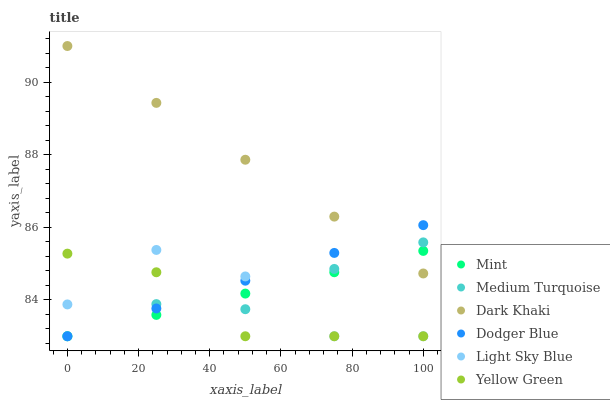Does Yellow Green have the minimum area under the curve?
Answer yes or no. Yes. Does Dark Khaki have the maximum area under the curve?
Answer yes or no. Yes. Does Light Sky Blue have the minimum area under the curve?
Answer yes or no. No. Does Light Sky Blue have the maximum area under the curve?
Answer yes or no. No. Is Dodger Blue the smoothest?
Answer yes or no. Yes. Is Light Sky Blue the roughest?
Answer yes or no. Yes. Is Dark Khaki the smoothest?
Answer yes or no. No. Is Dark Khaki the roughest?
Answer yes or no. No. Does Yellow Green have the lowest value?
Answer yes or no. Yes. Does Dark Khaki have the lowest value?
Answer yes or no. No. Does Dark Khaki have the highest value?
Answer yes or no. Yes. Does Light Sky Blue have the highest value?
Answer yes or no. No. Is Light Sky Blue less than Dark Khaki?
Answer yes or no. Yes. Is Dark Khaki greater than Yellow Green?
Answer yes or no. Yes. Does Mint intersect Dodger Blue?
Answer yes or no. Yes. Is Mint less than Dodger Blue?
Answer yes or no. No. Is Mint greater than Dodger Blue?
Answer yes or no. No. Does Light Sky Blue intersect Dark Khaki?
Answer yes or no. No. 